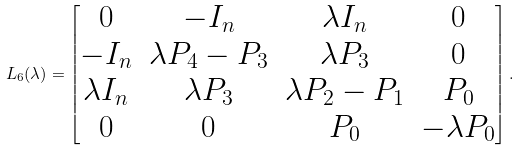Convert formula to latex. <formula><loc_0><loc_0><loc_500><loc_500>L _ { 6 } ( \lambda ) = \begin{bmatrix} 0 & - I _ { n } & \lambda I _ { n } & 0 \\ - I _ { n } & \lambda P _ { 4 } - P _ { 3 } & \lambda P _ { 3 } & 0 \\ \lambda I _ { n } & \lambda P _ { 3 } & \lambda P _ { 2 } - P _ { 1 } & P _ { 0 } \\ 0 & 0 & P _ { 0 } & - \lambda P _ { 0 } \end{bmatrix} .</formula> 